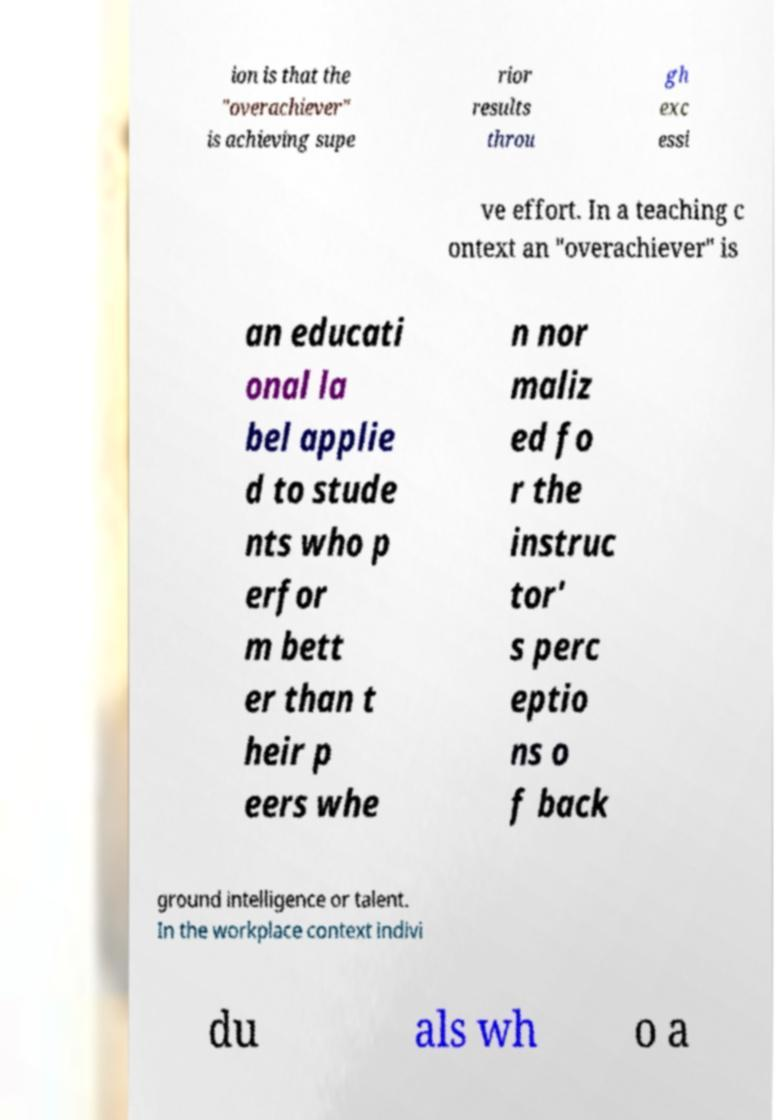Please read and relay the text visible in this image. What does it say? ion is that the "overachiever" is achieving supe rior results throu gh exc essi ve effort. In a teaching c ontext an "overachiever" is an educati onal la bel applie d to stude nts who p erfor m bett er than t heir p eers whe n nor maliz ed fo r the instruc tor' s perc eptio ns o f back ground intelligence or talent. In the workplace context indivi du als wh o a 